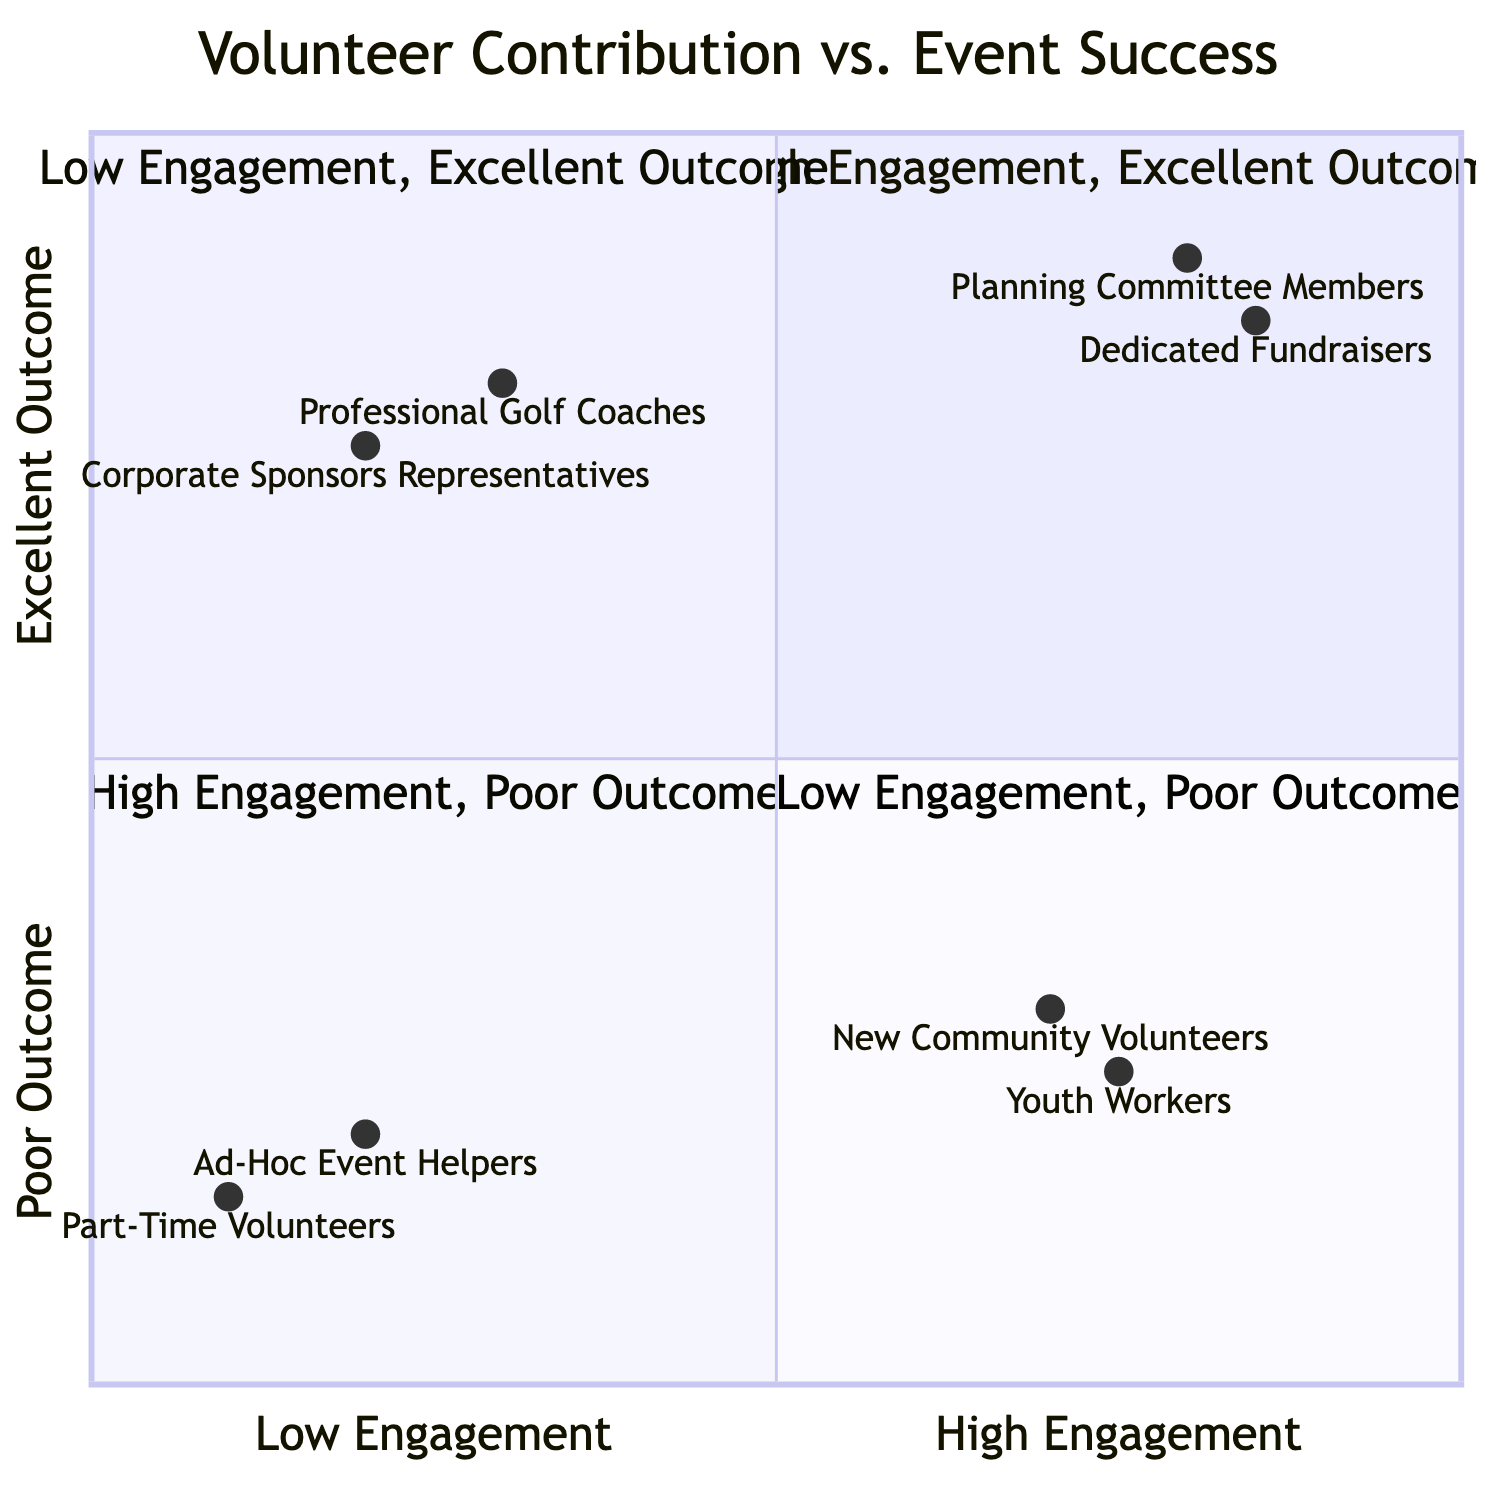What are the indicators of volunteers in the "High Engagement, Excellent Outcome" quadrant? The "High Engagement, Excellent Outcome" quadrant (Q1) includes volunteers who are significantly contributing to the success of the event. According to the data, examples of such volunteers are "Planning Committee Members" and "Dedicated Fundraisers."
Answer: Planning Committee Members, Dedicated Fundraisers Which quadrant has the most skilled professionals contributing? The "Low Engagement, Excellent Outcome" quadrant (Q2) features volunteers who may be less engaged but are highly effective in their roles, such as "Professional Golf Coaches" and "Corporate Sponsors Representatives." This indicates that their professional skills lead to an excellent event outcome despite lower engagement.
Answer: Low Engagement, Excellent Outcome How many volunteers are represented in the "Low Engagement, Poor Outcome" quadrant? The "Low Engagement, Poor Outcome" quadrant (Q4) contains two specific types of volunteers: "Ad-Hoc Event Helpers" and "Part-Time Volunteers." Therefore, there are two volunteers represented in this quadrant.
Answer: 2 What is the Y-axis value for "New Community Volunteers"? The "New Community Volunteers" are located in the "High Engagement, Poor Outcome" quadrant (Q3) with a Y-axis value of 0.3, indicating a poor event outcome despite high engagement levels.
Answer: 0.3 Which quadrant contains the most engaged volunteers facing challenges? The "High Engagement, Poor Outcome" quadrant (Q3) comprises volunteers who are actively engaged but still struggle to achieve high event success. "New Community Volunteers" and "Youth Workers" are examples from this quadrant, showing that active involvement does not guarantee effective results.
Answer: High Engagement, Poor Outcome How many quadrants indicate an excellent outcome? The diagram shows two quadrants with indicators of excellent outcomes: Q1 (High Engagement, Excellent Outcome) and Q2 (Low Engagement, Excellent Outcome), which suggests that both engaged and less engaged volunteers can contribute to successful events.
Answer: 2 Which volunteers are categorized as "Corporate Sponsors Representatives"? "Corporate Sponsors Representatives" are placed in the "Low Engagement, Excellent Outcome" quadrant (Q2). This indicates that although they have low engagement, their specialized role contributes positively to the event's success.
Answer: Low Engagement, Excellent Outcome How is "Dedicated Fundraisers" positioned on the chart? "Dedicated Fundraisers" are in the "High Engagement, Excellent Outcome" quadrant (Q1), which signifies they actively participate and significantly influence the success of the golf tournament.
Answer: High Engagement, Excellent Outcome 